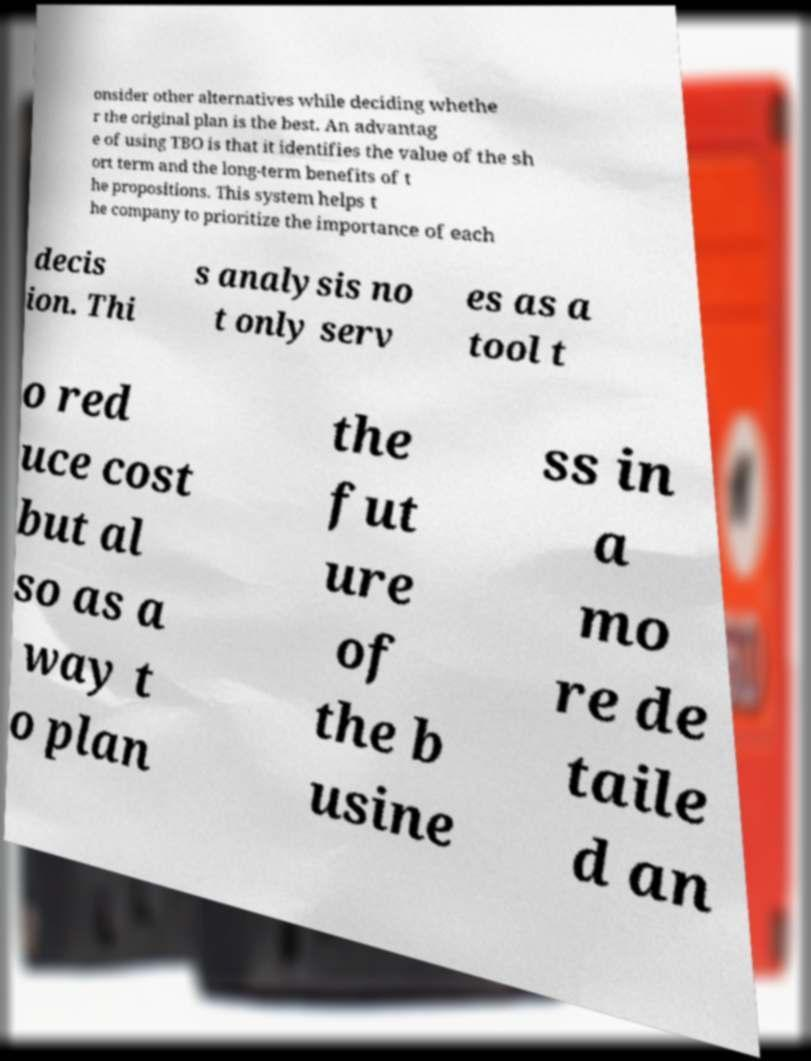Could you extract and type out the text from this image? onsider other alternatives while deciding whethe r the original plan is the best. An advantag e of using TBO is that it identifies the value of the sh ort term and the long-term benefits of t he propositions. This system helps t he company to prioritize the importance of each decis ion. Thi s analysis no t only serv es as a tool t o red uce cost but al so as a way t o plan the fut ure of the b usine ss in a mo re de taile d an 